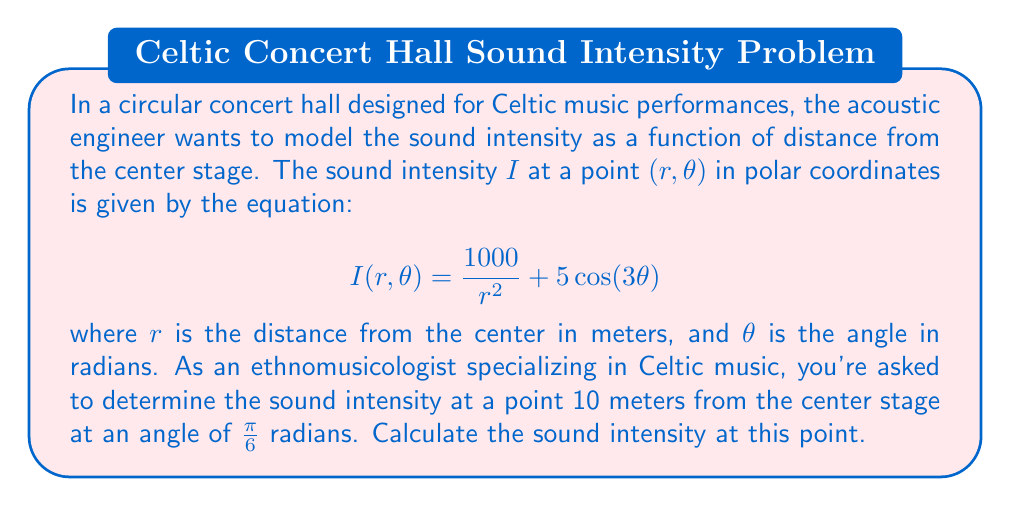What is the answer to this math problem? To solve this problem, we need to follow these steps:

1) We are given the equation for sound intensity in polar coordinates:

   $$I(r,\theta) = \frac{1000}{r^2} + 5\cos(3\theta)$$

2) We need to calculate the intensity at the point where:
   $r = 10$ meters
   $\theta = \frac{\pi}{6}$ radians

3) Let's substitute these values into our equation:

   $$I(10,\frac{\pi}{6}) = \frac{1000}{10^2} + 5\cos(3\cdot\frac{\pi}{6})$$

4) First, let's simplify the $\frac{1000}{r^2}$ term:
   
   $$\frac{1000}{10^2} = \frac{1000}{100} = 10$$

5) Now, let's calculate the $\cos(3\theta)$ term:
   
   $$\cos(3\cdot\frac{\pi}{6}) = \cos(\frac{\pi}{2}) = 0$$

6) Now we can add these terms:

   $$I(10,\frac{\pi}{6}) = 10 + 5(0) = 10$$

Therefore, the sound intensity at the given point is 10 units (which would typically be measured in watts per square meter, W/m²).
Answer: 10 W/m² 